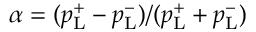Convert formula to latex. <formula><loc_0><loc_0><loc_500><loc_500>\alpha = ( p _ { L } ^ { + } - p _ { L } ^ { - } ) / ( p _ { L } ^ { + } + p _ { L } ^ { - } )</formula> 